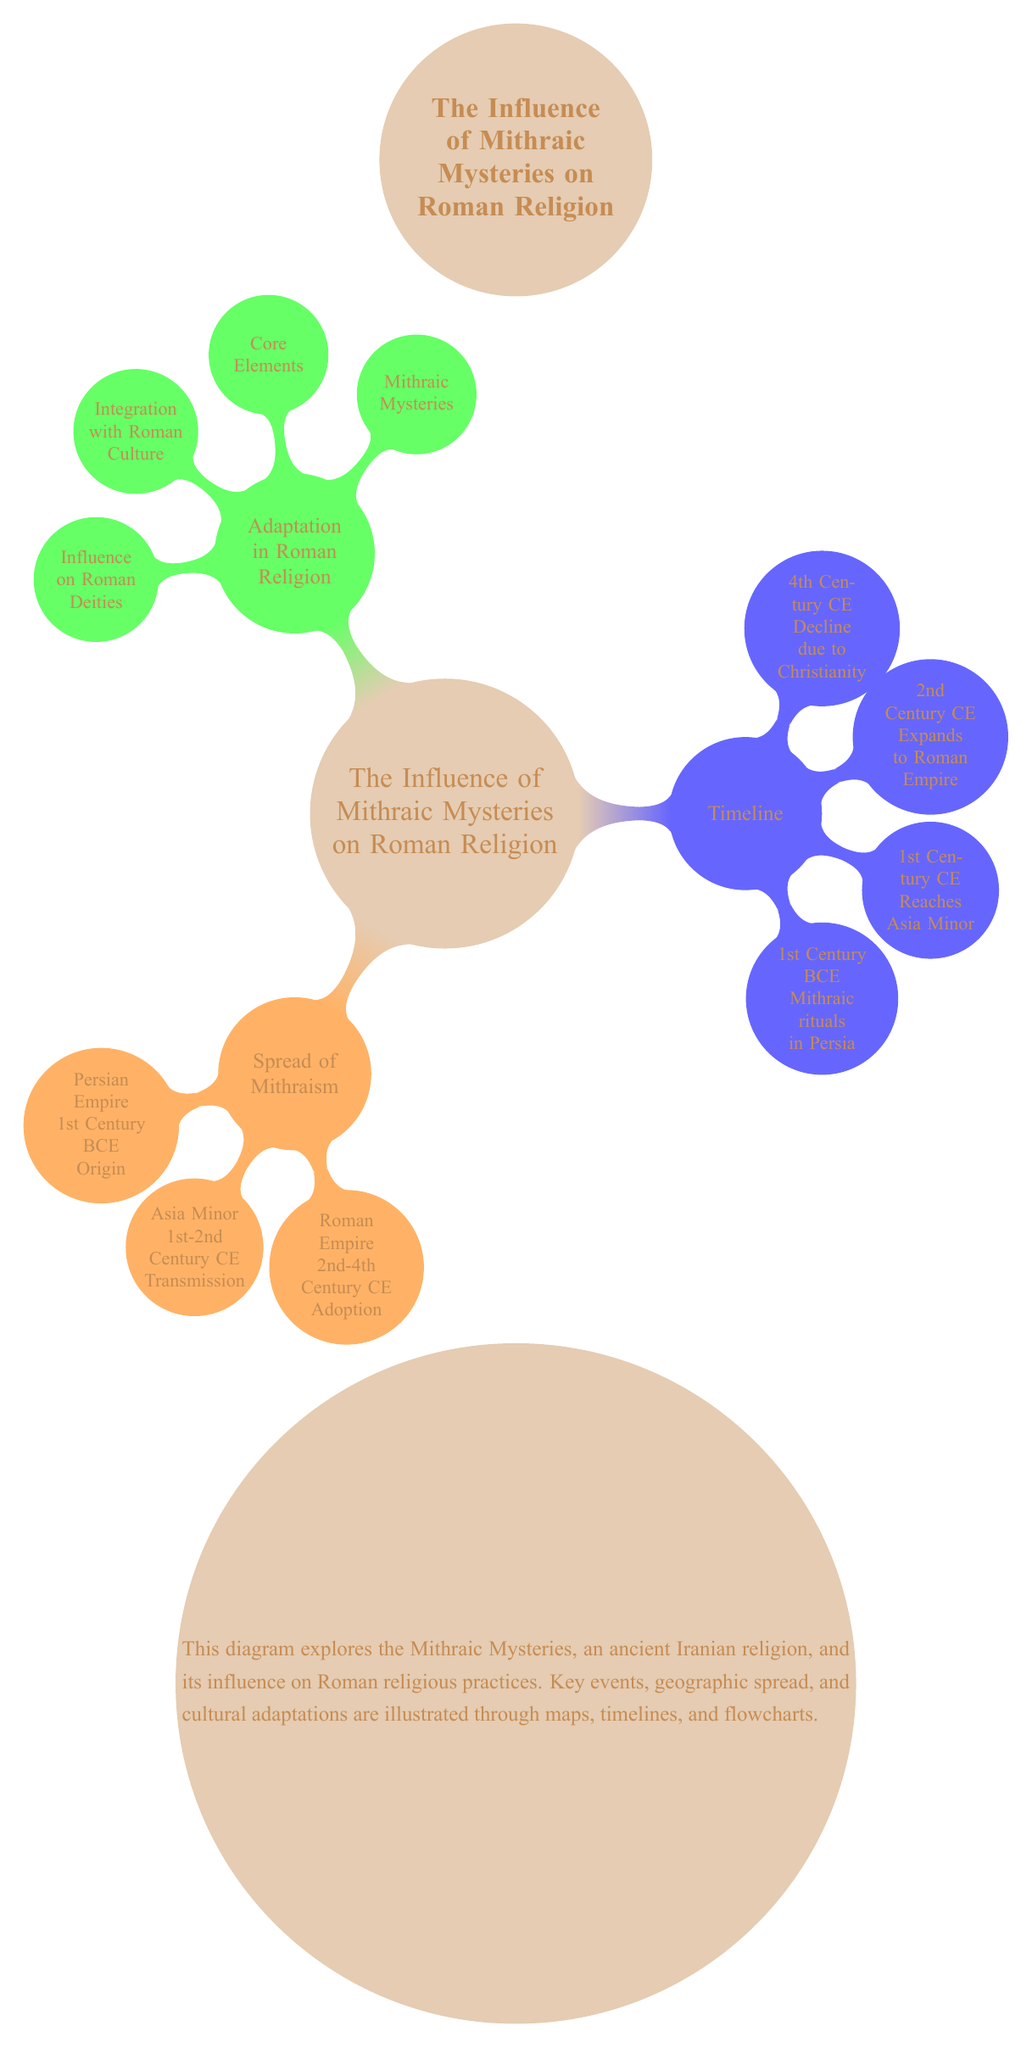What is the origin location of Mithraism? The diagram indicates that Mithraism originated in the Persian Empire during the 1st Century BCE. This is shown as the first child node under "Spread of Mithraism" where it details the specific origin point.
Answer: Persian Empire, 1st Century BCE Which century did Mithraism reach Asia Minor? According to the timeline section of the diagram, Mithraism reached Asia Minor in the 1st Century CE. This is explicitly stated in the timeline child node for that century.
Answer: 1st Century CE What are the core elements of Mithraic Mysteries? The diagram lists "Core Elements" as one of the child nodes under "Adaptation in Roman Religion," indicating its importance in understanding how Mithraism influenced Roman religion.
Answer: Core Elements What caused the decline of Mithraism? The diagram notes that Mithraism declined due to Christianity, which is specified as part of the timeline for the 4th Century CE. This indicates that the rise of Christianity had a direct impact on Mithraism's continued practice.
Answer: Christianity During which century did Mithraism expand to the Roman Empire? The timeline section of the diagram states that Mithraism expanded to the Roman Empire in the 2nd Century CE. This aligns with the flow of cultural and religious adaptation noted in the diagram.
Answer: 2nd Century CE How many main sections are there in the diagram? The diagram consists of three main sections: "Spread of Mithraism," "Timeline," and "Adaptation in Roman Religion." Counting these nodes gives the total number of sections.
Answer: Three Which color represents the "Adaptation in Roman Religion"? In the diagram, the color green is used to represent the "Adaptation in Roman Religion" section, making it easy to identify this specific area of content visually.
Answer: Green What relationship is illustrated between "Mithraic Mysteries" and "Integration with Roman Culture"? The diagram shows an edge indicating a direct relationship between "Mithraic Mysteries" and "Integration with Roman Culture," suggesting that the mysteries were integrated into Roman culture as they spread.
Answer: Edge (->) 